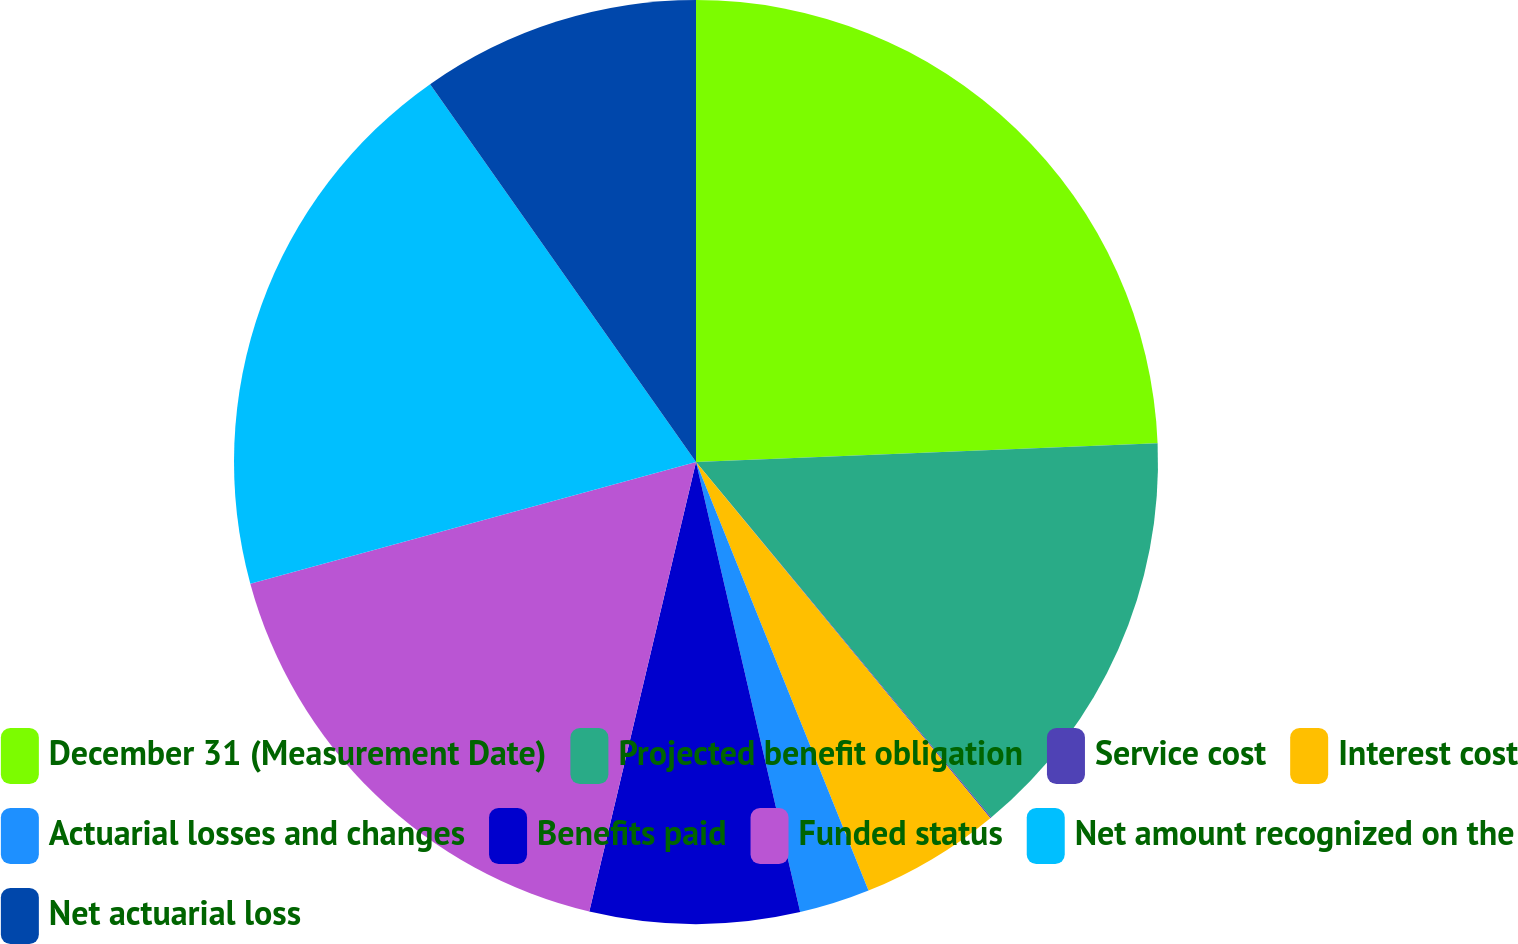Convert chart to OTSL. <chart><loc_0><loc_0><loc_500><loc_500><pie_chart><fcel>December 31 (Measurement Date)<fcel>Projected benefit obligation<fcel>Service cost<fcel>Interest cost<fcel>Actuarial losses and changes<fcel>Benefits paid<fcel>Funded status<fcel>Net amount recognized on the<fcel>Net actuarial loss<nl><fcel>24.35%<fcel>14.62%<fcel>0.04%<fcel>4.9%<fcel>2.47%<fcel>7.33%<fcel>17.05%<fcel>19.48%<fcel>9.76%<nl></chart> 